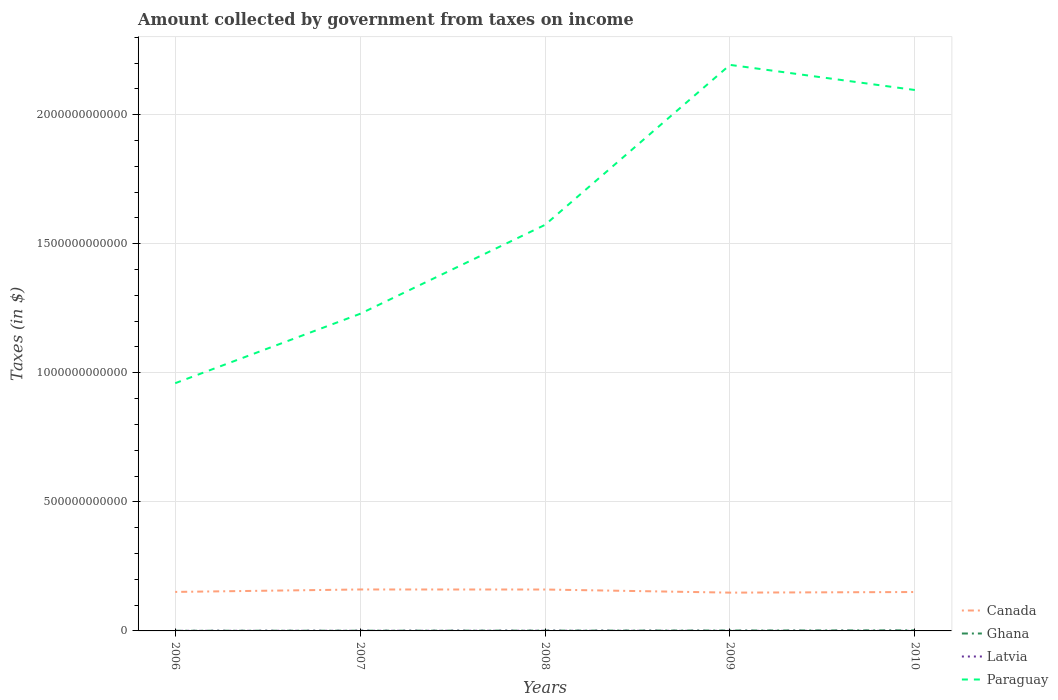How many different coloured lines are there?
Make the answer very short. 4. Is the number of lines equal to the number of legend labels?
Provide a short and direct response. Yes. Across all years, what is the maximum amount collected by government from taxes on income in Paraguay?
Your answer should be compact. 9.60e+11. What is the total amount collected by government from taxes on income in Canada in the graph?
Keep it short and to the point. 3.91e+08. What is the difference between the highest and the second highest amount collected by government from taxes on income in Canada?
Provide a succinct answer. 1.22e+1. Is the amount collected by government from taxes on income in Latvia strictly greater than the amount collected by government from taxes on income in Paraguay over the years?
Offer a very short reply. Yes. How many lines are there?
Your answer should be compact. 4. What is the difference between two consecutive major ticks on the Y-axis?
Give a very brief answer. 5.00e+11. Does the graph contain any zero values?
Offer a terse response. No. Does the graph contain grids?
Your answer should be compact. Yes. What is the title of the graph?
Your answer should be compact. Amount collected by government from taxes on income. What is the label or title of the Y-axis?
Offer a very short reply. Taxes (in $). What is the Taxes (in $) of Canada in 2006?
Ensure brevity in your answer.  1.51e+11. What is the Taxes (in $) in Ghana in 2006?
Keep it short and to the point. 6.58e+08. What is the Taxes (in $) of Latvia in 2006?
Your response must be concise. 4.18e+08. What is the Taxes (in $) of Paraguay in 2006?
Make the answer very short. 9.60e+11. What is the Taxes (in $) of Canada in 2007?
Your answer should be very brief. 1.61e+11. What is the Taxes (in $) of Ghana in 2007?
Your answer should be very brief. 8.57e+08. What is the Taxes (in $) in Latvia in 2007?
Offer a very short reply. 5.86e+08. What is the Taxes (in $) in Paraguay in 2007?
Ensure brevity in your answer.  1.23e+12. What is the Taxes (in $) of Canada in 2008?
Make the answer very short. 1.60e+11. What is the Taxes (in $) of Ghana in 2008?
Provide a succinct answer. 1.13e+09. What is the Taxes (in $) in Latvia in 2008?
Keep it short and to the point. 7.08e+08. What is the Taxes (in $) of Paraguay in 2008?
Give a very brief answer. 1.57e+12. What is the Taxes (in $) in Canada in 2009?
Keep it short and to the point. 1.48e+11. What is the Taxes (in $) of Ghana in 2009?
Keep it short and to the point. 1.54e+09. What is the Taxes (in $) in Latvia in 2009?
Provide a short and direct response. 3.22e+08. What is the Taxes (in $) in Paraguay in 2009?
Offer a very short reply. 2.19e+12. What is the Taxes (in $) of Canada in 2010?
Offer a very short reply. 1.51e+11. What is the Taxes (in $) in Ghana in 2010?
Your answer should be compact. 2.19e+09. What is the Taxes (in $) in Latvia in 2010?
Your response must be concise. 2.68e+08. What is the Taxes (in $) in Paraguay in 2010?
Your answer should be compact. 2.10e+12. Across all years, what is the maximum Taxes (in $) in Canada?
Make the answer very short. 1.61e+11. Across all years, what is the maximum Taxes (in $) in Ghana?
Keep it short and to the point. 2.19e+09. Across all years, what is the maximum Taxes (in $) in Latvia?
Offer a very short reply. 7.08e+08. Across all years, what is the maximum Taxes (in $) in Paraguay?
Your answer should be very brief. 2.19e+12. Across all years, what is the minimum Taxes (in $) in Canada?
Make the answer very short. 1.48e+11. Across all years, what is the minimum Taxes (in $) in Ghana?
Your answer should be very brief. 6.58e+08. Across all years, what is the minimum Taxes (in $) in Latvia?
Offer a very short reply. 2.68e+08. Across all years, what is the minimum Taxes (in $) of Paraguay?
Ensure brevity in your answer.  9.60e+11. What is the total Taxes (in $) of Canada in the graph?
Your answer should be very brief. 7.71e+11. What is the total Taxes (in $) of Ghana in the graph?
Your response must be concise. 6.38e+09. What is the total Taxes (in $) in Latvia in the graph?
Offer a terse response. 2.30e+09. What is the total Taxes (in $) in Paraguay in the graph?
Provide a succinct answer. 8.05e+12. What is the difference between the Taxes (in $) of Canada in 2006 and that in 2007?
Ensure brevity in your answer.  -9.50e+09. What is the difference between the Taxes (in $) in Ghana in 2006 and that in 2007?
Your answer should be compact. -1.99e+08. What is the difference between the Taxes (in $) in Latvia in 2006 and that in 2007?
Offer a very short reply. -1.68e+08. What is the difference between the Taxes (in $) of Paraguay in 2006 and that in 2007?
Keep it short and to the point. -2.69e+11. What is the difference between the Taxes (in $) of Canada in 2006 and that in 2008?
Offer a terse response. -9.34e+09. What is the difference between the Taxes (in $) in Ghana in 2006 and that in 2008?
Offer a very short reply. -4.77e+08. What is the difference between the Taxes (in $) in Latvia in 2006 and that in 2008?
Offer a terse response. -2.90e+08. What is the difference between the Taxes (in $) of Paraguay in 2006 and that in 2008?
Give a very brief answer. -6.13e+11. What is the difference between the Taxes (in $) of Canada in 2006 and that in 2009?
Make the answer very short. 2.73e+09. What is the difference between the Taxes (in $) in Ghana in 2006 and that in 2009?
Your answer should be very brief. -8.80e+08. What is the difference between the Taxes (in $) of Latvia in 2006 and that in 2009?
Give a very brief answer. 9.61e+07. What is the difference between the Taxes (in $) of Paraguay in 2006 and that in 2009?
Keep it short and to the point. -1.23e+12. What is the difference between the Taxes (in $) of Canada in 2006 and that in 2010?
Give a very brief answer. 3.91e+08. What is the difference between the Taxes (in $) of Ghana in 2006 and that in 2010?
Your answer should be very brief. -1.54e+09. What is the difference between the Taxes (in $) of Latvia in 2006 and that in 2010?
Ensure brevity in your answer.  1.50e+08. What is the difference between the Taxes (in $) in Paraguay in 2006 and that in 2010?
Offer a terse response. -1.14e+12. What is the difference between the Taxes (in $) of Canada in 2007 and that in 2008?
Ensure brevity in your answer.  1.59e+08. What is the difference between the Taxes (in $) in Ghana in 2007 and that in 2008?
Provide a succinct answer. -2.77e+08. What is the difference between the Taxes (in $) in Latvia in 2007 and that in 2008?
Ensure brevity in your answer.  -1.22e+08. What is the difference between the Taxes (in $) of Paraguay in 2007 and that in 2008?
Provide a succinct answer. -3.45e+11. What is the difference between the Taxes (in $) of Canada in 2007 and that in 2009?
Offer a very short reply. 1.22e+1. What is the difference between the Taxes (in $) in Ghana in 2007 and that in 2009?
Give a very brief answer. -6.81e+08. What is the difference between the Taxes (in $) in Latvia in 2007 and that in 2009?
Provide a succinct answer. 2.65e+08. What is the difference between the Taxes (in $) in Paraguay in 2007 and that in 2009?
Offer a terse response. -9.64e+11. What is the difference between the Taxes (in $) in Canada in 2007 and that in 2010?
Your response must be concise. 9.89e+09. What is the difference between the Taxes (in $) of Ghana in 2007 and that in 2010?
Offer a terse response. -1.34e+09. What is the difference between the Taxes (in $) in Latvia in 2007 and that in 2010?
Keep it short and to the point. 3.18e+08. What is the difference between the Taxes (in $) of Paraguay in 2007 and that in 2010?
Keep it short and to the point. -8.67e+11. What is the difference between the Taxes (in $) in Canada in 2008 and that in 2009?
Your response must be concise. 1.21e+1. What is the difference between the Taxes (in $) in Ghana in 2008 and that in 2009?
Give a very brief answer. -4.04e+08. What is the difference between the Taxes (in $) of Latvia in 2008 and that in 2009?
Provide a short and direct response. 3.86e+08. What is the difference between the Taxes (in $) in Paraguay in 2008 and that in 2009?
Provide a short and direct response. -6.20e+11. What is the difference between the Taxes (in $) of Canada in 2008 and that in 2010?
Offer a very short reply. 9.73e+09. What is the difference between the Taxes (in $) in Ghana in 2008 and that in 2010?
Your response must be concise. -1.06e+09. What is the difference between the Taxes (in $) of Latvia in 2008 and that in 2010?
Your answer should be very brief. 4.40e+08. What is the difference between the Taxes (in $) in Paraguay in 2008 and that in 2010?
Provide a short and direct response. -5.22e+11. What is the difference between the Taxes (in $) of Canada in 2009 and that in 2010?
Give a very brief answer. -2.34e+09. What is the difference between the Taxes (in $) of Ghana in 2009 and that in 2010?
Offer a terse response. -6.57e+08. What is the difference between the Taxes (in $) in Latvia in 2009 and that in 2010?
Offer a very short reply. 5.39e+07. What is the difference between the Taxes (in $) in Paraguay in 2009 and that in 2010?
Make the answer very short. 9.73e+1. What is the difference between the Taxes (in $) in Canada in 2006 and the Taxes (in $) in Ghana in 2007?
Give a very brief answer. 1.50e+11. What is the difference between the Taxes (in $) of Canada in 2006 and the Taxes (in $) of Latvia in 2007?
Offer a very short reply. 1.50e+11. What is the difference between the Taxes (in $) of Canada in 2006 and the Taxes (in $) of Paraguay in 2007?
Provide a succinct answer. -1.08e+12. What is the difference between the Taxes (in $) of Ghana in 2006 and the Taxes (in $) of Latvia in 2007?
Your answer should be compact. 7.20e+07. What is the difference between the Taxes (in $) of Ghana in 2006 and the Taxes (in $) of Paraguay in 2007?
Give a very brief answer. -1.23e+12. What is the difference between the Taxes (in $) of Latvia in 2006 and the Taxes (in $) of Paraguay in 2007?
Give a very brief answer. -1.23e+12. What is the difference between the Taxes (in $) of Canada in 2006 and the Taxes (in $) of Ghana in 2008?
Offer a very short reply. 1.50e+11. What is the difference between the Taxes (in $) of Canada in 2006 and the Taxes (in $) of Latvia in 2008?
Offer a terse response. 1.50e+11. What is the difference between the Taxes (in $) in Canada in 2006 and the Taxes (in $) in Paraguay in 2008?
Your answer should be very brief. -1.42e+12. What is the difference between the Taxes (in $) of Ghana in 2006 and the Taxes (in $) of Latvia in 2008?
Give a very brief answer. -4.98e+07. What is the difference between the Taxes (in $) in Ghana in 2006 and the Taxes (in $) in Paraguay in 2008?
Provide a short and direct response. -1.57e+12. What is the difference between the Taxes (in $) in Latvia in 2006 and the Taxes (in $) in Paraguay in 2008?
Keep it short and to the point. -1.57e+12. What is the difference between the Taxes (in $) in Canada in 2006 and the Taxes (in $) in Ghana in 2009?
Offer a terse response. 1.50e+11. What is the difference between the Taxes (in $) of Canada in 2006 and the Taxes (in $) of Latvia in 2009?
Your answer should be very brief. 1.51e+11. What is the difference between the Taxes (in $) in Canada in 2006 and the Taxes (in $) in Paraguay in 2009?
Give a very brief answer. -2.04e+12. What is the difference between the Taxes (in $) in Ghana in 2006 and the Taxes (in $) in Latvia in 2009?
Keep it short and to the point. 3.37e+08. What is the difference between the Taxes (in $) in Ghana in 2006 and the Taxes (in $) in Paraguay in 2009?
Ensure brevity in your answer.  -2.19e+12. What is the difference between the Taxes (in $) in Latvia in 2006 and the Taxes (in $) in Paraguay in 2009?
Your response must be concise. -2.19e+12. What is the difference between the Taxes (in $) of Canada in 2006 and the Taxes (in $) of Ghana in 2010?
Your answer should be compact. 1.49e+11. What is the difference between the Taxes (in $) of Canada in 2006 and the Taxes (in $) of Latvia in 2010?
Provide a short and direct response. 1.51e+11. What is the difference between the Taxes (in $) of Canada in 2006 and the Taxes (in $) of Paraguay in 2010?
Give a very brief answer. -1.94e+12. What is the difference between the Taxes (in $) in Ghana in 2006 and the Taxes (in $) in Latvia in 2010?
Ensure brevity in your answer.  3.90e+08. What is the difference between the Taxes (in $) of Ghana in 2006 and the Taxes (in $) of Paraguay in 2010?
Your answer should be compact. -2.09e+12. What is the difference between the Taxes (in $) in Latvia in 2006 and the Taxes (in $) in Paraguay in 2010?
Offer a very short reply. -2.10e+12. What is the difference between the Taxes (in $) of Canada in 2007 and the Taxes (in $) of Ghana in 2008?
Your answer should be compact. 1.59e+11. What is the difference between the Taxes (in $) in Canada in 2007 and the Taxes (in $) in Latvia in 2008?
Make the answer very short. 1.60e+11. What is the difference between the Taxes (in $) of Canada in 2007 and the Taxes (in $) of Paraguay in 2008?
Keep it short and to the point. -1.41e+12. What is the difference between the Taxes (in $) in Ghana in 2007 and the Taxes (in $) in Latvia in 2008?
Give a very brief answer. 1.49e+08. What is the difference between the Taxes (in $) in Ghana in 2007 and the Taxes (in $) in Paraguay in 2008?
Provide a succinct answer. -1.57e+12. What is the difference between the Taxes (in $) of Latvia in 2007 and the Taxes (in $) of Paraguay in 2008?
Give a very brief answer. -1.57e+12. What is the difference between the Taxes (in $) in Canada in 2007 and the Taxes (in $) in Ghana in 2009?
Your answer should be compact. 1.59e+11. What is the difference between the Taxes (in $) of Canada in 2007 and the Taxes (in $) of Latvia in 2009?
Offer a very short reply. 1.60e+11. What is the difference between the Taxes (in $) in Canada in 2007 and the Taxes (in $) in Paraguay in 2009?
Offer a terse response. -2.03e+12. What is the difference between the Taxes (in $) in Ghana in 2007 and the Taxes (in $) in Latvia in 2009?
Offer a terse response. 5.36e+08. What is the difference between the Taxes (in $) of Ghana in 2007 and the Taxes (in $) of Paraguay in 2009?
Your answer should be compact. -2.19e+12. What is the difference between the Taxes (in $) of Latvia in 2007 and the Taxes (in $) of Paraguay in 2009?
Offer a very short reply. -2.19e+12. What is the difference between the Taxes (in $) in Canada in 2007 and the Taxes (in $) in Ghana in 2010?
Offer a terse response. 1.58e+11. What is the difference between the Taxes (in $) of Canada in 2007 and the Taxes (in $) of Latvia in 2010?
Your answer should be very brief. 1.60e+11. What is the difference between the Taxes (in $) in Canada in 2007 and the Taxes (in $) in Paraguay in 2010?
Provide a succinct answer. -1.94e+12. What is the difference between the Taxes (in $) in Ghana in 2007 and the Taxes (in $) in Latvia in 2010?
Your answer should be very brief. 5.90e+08. What is the difference between the Taxes (in $) in Ghana in 2007 and the Taxes (in $) in Paraguay in 2010?
Give a very brief answer. -2.09e+12. What is the difference between the Taxes (in $) in Latvia in 2007 and the Taxes (in $) in Paraguay in 2010?
Offer a terse response. -2.10e+12. What is the difference between the Taxes (in $) in Canada in 2008 and the Taxes (in $) in Ghana in 2009?
Provide a short and direct response. 1.59e+11. What is the difference between the Taxes (in $) of Canada in 2008 and the Taxes (in $) of Latvia in 2009?
Provide a succinct answer. 1.60e+11. What is the difference between the Taxes (in $) in Canada in 2008 and the Taxes (in $) in Paraguay in 2009?
Keep it short and to the point. -2.03e+12. What is the difference between the Taxes (in $) of Ghana in 2008 and the Taxes (in $) of Latvia in 2009?
Your answer should be compact. 8.13e+08. What is the difference between the Taxes (in $) of Ghana in 2008 and the Taxes (in $) of Paraguay in 2009?
Your answer should be compact. -2.19e+12. What is the difference between the Taxes (in $) of Latvia in 2008 and the Taxes (in $) of Paraguay in 2009?
Your response must be concise. -2.19e+12. What is the difference between the Taxes (in $) in Canada in 2008 and the Taxes (in $) in Ghana in 2010?
Make the answer very short. 1.58e+11. What is the difference between the Taxes (in $) of Canada in 2008 and the Taxes (in $) of Latvia in 2010?
Offer a very short reply. 1.60e+11. What is the difference between the Taxes (in $) in Canada in 2008 and the Taxes (in $) in Paraguay in 2010?
Your answer should be very brief. -1.94e+12. What is the difference between the Taxes (in $) in Ghana in 2008 and the Taxes (in $) in Latvia in 2010?
Your answer should be very brief. 8.67e+08. What is the difference between the Taxes (in $) in Ghana in 2008 and the Taxes (in $) in Paraguay in 2010?
Provide a short and direct response. -2.09e+12. What is the difference between the Taxes (in $) in Latvia in 2008 and the Taxes (in $) in Paraguay in 2010?
Keep it short and to the point. -2.09e+12. What is the difference between the Taxes (in $) of Canada in 2009 and the Taxes (in $) of Ghana in 2010?
Ensure brevity in your answer.  1.46e+11. What is the difference between the Taxes (in $) in Canada in 2009 and the Taxes (in $) in Latvia in 2010?
Your response must be concise. 1.48e+11. What is the difference between the Taxes (in $) in Canada in 2009 and the Taxes (in $) in Paraguay in 2010?
Keep it short and to the point. -1.95e+12. What is the difference between the Taxes (in $) of Ghana in 2009 and the Taxes (in $) of Latvia in 2010?
Your answer should be very brief. 1.27e+09. What is the difference between the Taxes (in $) in Ghana in 2009 and the Taxes (in $) in Paraguay in 2010?
Your response must be concise. -2.09e+12. What is the difference between the Taxes (in $) of Latvia in 2009 and the Taxes (in $) of Paraguay in 2010?
Offer a terse response. -2.10e+12. What is the average Taxes (in $) in Canada per year?
Offer a terse response. 1.54e+11. What is the average Taxes (in $) in Ghana per year?
Provide a short and direct response. 1.28e+09. What is the average Taxes (in $) in Latvia per year?
Offer a very short reply. 4.60e+08. What is the average Taxes (in $) in Paraguay per year?
Ensure brevity in your answer.  1.61e+12. In the year 2006, what is the difference between the Taxes (in $) in Canada and Taxes (in $) in Ghana?
Your response must be concise. 1.50e+11. In the year 2006, what is the difference between the Taxes (in $) of Canada and Taxes (in $) of Latvia?
Provide a short and direct response. 1.51e+11. In the year 2006, what is the difference between the Taxes (in $) in Canada and Taxes (in $) in Paraguay?
Keep it short and to the point. -8.09e+11. In the year 2006, what is the difference between the Taxes (in $) of Ghana and Taxes (in $) of Latvia?
Your response must be concise. 2.40e+08. In the year 2006, what is the difference between the Taxes (in $) in Ghana and Taxes (in $) in Paraguay?
Offer a terse response. -9.59e+11. In the year 2006, what is the difference between the Taxes (in $) in Latvia and Taxes (in $) in Paraguay?
Your answer should be very brief. -9.59e+11. In the year 2007, what is the difference between the Taxes (in $) in Canada and Taxes (in $) in Ghana?
Offer a terse response. 1.60e+11. In the year 2007, what is the difference between the Taxes (in $) of Canada and Taxes (in $) of Latvia?
Provide a succinct answer. 1.60e+11. In the year 2007, what is the difference between the Taxes (in $) of Canada and Taxes (in $) of Paraguay?
Keep it short and to the point. -1.07e+12. In the year 2007, what is the difference between the Taxes (in $) in Ghana and Taxes (in $) in Latvia?
Offer a terse response. 2.71e+08. In the year 2007, what is the difference between the Taxes (in $) of Ghana and Taxes (in $) of Paraguay?
Provide a succinct answer. -1.23e+12. In the year 2007, what is the difference between the Taxes (in $) in Latvia and Taxes (in $) in Paraguay?
Give a very brief answer. -1.23e+12. In the year 2008, what is the difference between the Taxes (in $) of Canada and Taxes (in $) of Ghana?
Make the answer very short. 1.59e+11. In the year 2008, what is the difference between the Taxes (in $) of Canada and Taxes (in $) of Latvia?
Provide a short and direct response. 1.60e+11. In the year 2008, what is the difference between the Taxes (in $) of Canada and Taxes (in $) of Paraguay?
Your answer should be compact. -1.41e+12. In the year 2008, what is the difference between the Taxes (in $) in Ghana and Taxes (in $) in Latvia?
Give a very brief answer. 4.27e+08. In the year 2008, what is the difference between the Taxes (in $) in Ghana and Taxes (in $) in Paraguay?
Your response must be concise. -1.57e+12. In the year 2008, what is the difference between the Taxes (in $) in Latvia and Taxes (in $) in Paraguay?
Keep it short and to the point. -1.57e+12. In the year 2009, what is the difference between the Taxes (in $) in Canada and Taxes (in $) in Ghana?
Ensure brevity in your answer.  1.47e+11. In the year 2009, what is the difference between the Taxes (in $) of Canada and Taxes (in $) of Latvia?
Keep it short and to the point. 1.48e+11. In the year 2009, what is the difference between the Taxes (in $) in Canada and Taxes (in $) in Paraguay?
Offer a terse response. -2.04e+12. In the year 2009, what is the difference between the Taxes (in $) of Ghana and Taxes (in $) of Latvia?
Your response must be concise. 1.22e+09. In the year 2009, what is the difference between the Taxes (in $) in Ghana and Taxes (in $) in Paraguay?
Provide a succinct answer. -2.19e+12. In the year 2009, what is the difference between the Taxes (in $) in Latvia and Taxes (in $) in Paraguay?
Offer a terse response. -2.19e+12. In the year 2010, what is the difference between the Taxes (in $) of Canada and Taxes (in $) of Ghana?
Provide a succinct answer. 1.48e+11. In the year 2010, what is the difference between the Taxes (in $) in Canada and Taxes (in $) in Latvia?
Keep it short and to the point. 1.50e+11. In the year 2010, what is the difference between the Taxes (in $) of Canada and Taxes (in $) of Paraguay?
Your answer should be very brief. -1.94e+12. In the year 2010, what is the difference between the Taxes (in $) in Ghana and Taxes (in $) in Latvia?
Give a very brief answer. 1.93e+09. In the year 2010, what is the difference between the Taxes (in $) of Ghana and Taxes (in $) of Paraguay?
Give a very brief answer. -2.09e+12. In the year 2010, what is the difference between the Taxes (in $) of Latvia and Taxes (in $) of Paraguay?
Provide a succinct answer. -2.10e+12. What is the ratio of the Taxes (in $) of Canada in 2006 to that in 2007?
Give a very brief answer. 0.94. What is the ratio of the Taxes (in $) in Ghana in 2006 to that in 2007?
Your answer should be compact. 0.77. What is the ratio of the Taxes (in $) in Latvia in 2006 to that in 2007?
Keep it short and to the point. 0.71. What is the ratio of the Taxes (in $) of Paraguay in 2006 to that in 2007?
Your answer should be compact. 0.78. What is the ratio of the Taxes (in $) in Canada in 2006 to that in 2008?
Ensure brevity in your answer.  0.94. What is the ratio of the Taxes (in $) in Ghana in 2006 to that in 2008?
Offer a very short reply. 0.58. What is the ratio of the Taxes (in $) in Latvia in 2006 to that in 2008?
Your answer should be very brief. 0.59. What is the ratio of the Taxes (in $) in Paraguay in 2006 to that in 2008?
Provide a succinct answer. 0.61. What is the ratio of the Taxes (in $) of Canada in 2006 to that in 2009?
Your response must be concise. 1.02. What is the ratio of the Taxes (in $) of Ghana in 2006 to that in 2009?
Your answer should be compact. 0.43. What is the ratio of the Taxes (in $) of Latvia in 2006 to that in 2009?
Provide a short and direct response. 1.3. What is the ratio of the Taxes (in $) of Paraguay in 2006 to that in 2009?
Give a very brief answer. 0.44. What is the ratio of the Taxes (in $) of Canada in 2006 to that in 2010?
Give a very brief answer. 1. What is the ratio of the Taxes (in $) in Ghana in 2006 to that in 2010?
Make the answer very short. 0.3. What is the ratio of the Taxes (in $) of Latvia in 2006 to that in 2010?
Ensure brevity in your answer.  1.56. What is the ratio of the Taxes (in $) of Paraguay in 2006 to that in 2010?
Ensure brevity in your answer.  0.46. What is the ratio of the Taxes (in $) in Canada in 2007 to that in 2008?
Give a very brief answer. 1. What is the ratio of the Taxes (in $) in Ghana in 2007 to that in 2008?
Provide a short and direct response. 0.76. What is the ratio of the Taxes (in $) in Latvia in 2007 to that in 2008?
Make the answer very short. 0.83. What is the ratio of the Taxes (in $) in Paraguay in 2007 to that in 2008?
Ensure brevity in your answer.  0.78. What is the ratio of the Taxes (in $) of Canada in 2007 to that in 2009?
Offer a terse response. 1.08. What is the ratio of the Taxes (in $) of Ghana in 2007 to that in 2009?
Your answer should be very brief. 0.56. What is the ratio of the Taxes (in $) in Latvia in 2007 to that in 2009?
Offer a very short reply. 1.82. What is the ratio of the Taxes (in $) in Paraguay in 2007 to that in 2009?
Provide a succinct answer. 0.56. What is the ratio of the Taxes (in $) of Canada in 2007 to that in 2010?
Your response must be concise. 1.07. What is the ratio of the Taxes (in $) of Ghana in 2007 to that in 2010?
Offer a very short reply. 0.39. What is the ratio of the Taxes (in $) of Latvia in 2007 to that in 2010?
Give a very brief answer. 2.19. What is the ratio of the Taxes (in $) of Paraguay in 2007 to that in 2010?
Ensure brevity in your answer.  0.59. What is the ratio of the Taxes (in $) of Canada in 2008 to that in 2009?
Give a very brief answer. 1.08. What is the ratio of the Taxes (in $) in Ghana in 2008 to that in 2009?
Your response must be concise. 0.74. What is the ratio of the Taxes (in $) in Latvia in 2008 to that in 2009?
Ensure brevity in your answer.  2.2. What is the ratio of the Taxes (in $) of Paraguay in 2008 to that in 2009?
Your response must be concise. 0.72. What is the ratio of the Taxes (in $) in Canada in 2008 to that in 2010?
Make the answer very short. 1.06. What is the ratio of the Taxes (in $) in Ghana in 2008 to that in 2010?
Your answer should be compact. 0.52. What is the ratio of the Taxes (in $) in Latvia in 2008 to that in 2010?
Keep it short and to the point. 2.64. What is the ratio of the Taxes (in $) in Paraguay in 2008 to that in 2010?
Make the answer very short. 0.75. What is the ratio of the Taxes (in $) of Canada in 2009 to that in 2010?
Give a very brief answer. 0.98. What is the ratio of the Taxes (in $) of Ghana in 2009 to that in 2010?
Offer a terse response. 0.7. What is the ratio of the Taxes (in $) in Latvia in 2009 to that in 2010?
Ensure brevity in your answer.  1.2. What is the ratio of the Taxes (in $) of Paraguay in 2009 to that in 2010?
Your answer should be compact. 1.05. What is the difference between the highest and the second highest Taxes (in $) of Canada?
Your response must be concise. 1.59e+08. What is the difference between the highest and the second highest Taxes (in $) of Ghana?
Your response must be concise. 6.57e+08. What is the difference between the highest and the second highest Taxes (in $) of Latvia?
Keep it short and to the point. 1.22e+08. What is the difference between the highest and the second highest Taxes (in $) of Paraguay?
Your response must be concise. 9.73e+1. What is the difference between the highest and the lowest Taxes (in $) in Canada?
Your answer should be compact. 1.22e+1. What is the difference between the highest and the lowest Taxes (in $) of Ghana?
Give a very brief answer. 1.54e+09. What is the difference between the highest and the lowest Taxes (in $) of Latvia?
Offer a very short reply. 4.40e+08. What is the difference between the highest and the lowest Taxes (in $) in Paraguay?
Offer a terse response. 1.23e+12. 